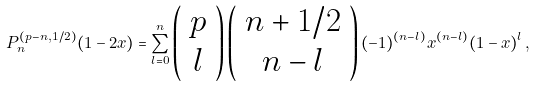<formula> <loc_0><loc_0><loc_500><loc_500>P _ { n } ^ { ( p - n , 1 / 2 ) } ( 1 - 2 x ) = \sum _ { l = 0 } ^ { n } \left ( \begin{array} { c } p \\ l \end{array} \right ) \left ( \begin{array} { c } n + 1 / 2 \\ n - l \end{array} \right ) ( - 1 ) ^ { ( n - l ) } x ^ { ( n - l ) } ( 1 - x ) ^ { l } \, ,</formula> 